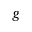Convert formula to latex. <formula><loc_0><loc_0><loc_500><loc_500>g</formula> 